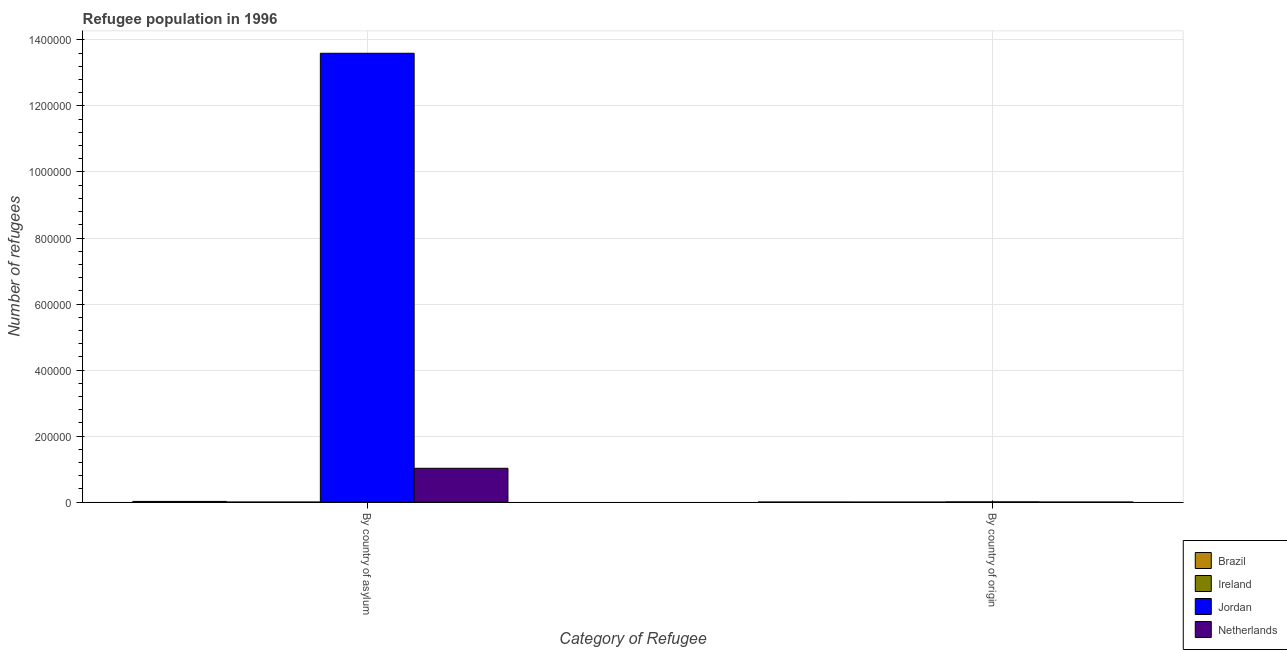Are the number of bars per tick equal to the number of legend labels?
Your response must be concise. Yes. Are the number of bars on each tick of the X-axis equal?
Keep it short and to the point. Yes. What is the label of the 1st group of bars from the left?
Make the answer very short. By country of asylum. What is the number of refugees by country of asylum in Ireland?
Keep it short and to the point. 69. Across all countries, what is the maximum number of refugees by country of origin?
Offer a very short reply. 708. Across all countries, what is the minimum number of refugees by country of asylum?
Give a very brief answer. 69. In which country was the number of refugees by country of origin maximum?
Your response must be concise. Jordan. In which country was the number of refugees by country of origin minimum?
Offer a terse response. Ireland. What is the total number of refugees by country of asylum in the graph?
Ensure brevity in your answer.  1.46e+06. What is the difference between the number of refugees by country of asylum in Netherlands and that in Jordan?
Offer a very short reply. -1.26e+06. What is the difference between the number of refugees by country of origin in Netherlands and the number of refugees by country of asylum in Ireland?
Give a very brief answer. 27. What is the average number of refugees by country of asylum per country?
Keep it short and to the point. 3.66e+05. What is the difference between the number of refugees by country of origin and number of refugees by country of asylum in Brazil?
Offer a terse response. -2127. What is the ratio of the number of refugees by country of origin in Brazil to that in Netherlands?
Provide a short and direct response. 0.89. Is the number of refugees by country of asylum in Jordan less than that in Ireland?
Offer a terse response. No. What does the 4th bar from the right in By country of asylum represents?
Your answer should be very brief. Brazil. What is the difference between two consecutive major ticks on the Y-axis?
Offer a terse response. 2.00e+05. Are the values on the major ticks of Y-axis written in scientific E-notation?
Provide a succinct answer. No. Does the graph contain any zero values?
Offer a terse response. No. How are the legend labels stacked?
Give a very brief answer. Vertical. What is the title of the graph?
Make the answer very short. Refugee population in 1996. What is the label or title of the X-axis?
Offer a terse response. Category of Refugee. What is the label or title of the Y-axis?
Provide a succinct answer. Number of refugees. What is the Number of refugees in Brazil in By country of asylum?
Offer a very short reply. 2212. What is the Number of refugees of Jordan in By country of asylum?
Keep it short and to the point. 1.36e+06. What is the Number of refugees in Netherlands in By country of asylum?
Provide a succinct answer. 1.03e+05. What is the Number of refugees in Ireland in By country of origin?
Your answer should be very brief. 2. What is the Number of refugees in Jordan in By country of origin?
Your response must be concise. 708. What is the Number of refugees of Netherlands in By country of origin?
Your answer should be very brief. 96. Across all Category of Refugee, what is the maximum Number of refugees of Brazil?
Ensure brevity in your answer.  2212. Across all Category of Refugee, what is the maximum Number of refugees in Jordan?
Offer a terse response. 1.36e+06. Across all Category of Refugee, what is the maximum Number of refugees of Netherlands?
Offer a very short reply. 1.03e+05. Across all Category of Refugee, what is the minimum Number of refugees in Ireland?
Ensure brevity in your answer.  2. Across all Category of Refugee, what is the minimum Number of refugees in Jordan?
Keep it short and to the point. 708. Across all Category of Refugee, what is the minimum Number of refugees in Netherlands?
Provide a succinct answer. 96. What is the total Number of refugees in Brazil in the graph?
Give a very brief answer. 2297. What is the total Number of refugees in Ireland in the graph?
Provide a short and direct response. 71. What is the total Number of refugees of Jordan in the graph?
Make the answer very short. 1.36e+06. What is the total Number of refugees in Netherlands in the graph?
Offer a very short reply. 1.03e+05. What is the difference between the Number of refugees of Brazil in By country of asylum and that in By country of origin?
Your answer should be very brief. 2127. What is the difference between the Number of refugees in Jordan in By country of asylum and that in By country of origin?
Your answer should be compact. 1.36e+06. What is the difference between the Number of refugees in Netherlands in By country of asylum and that in By country of origin?
Ensure brevity in your answer.  1.02e+05. What is the difference between the Number of refugees of Brazil in By country of asylum and the Number of refugees of Ireland in By country of origin?
Keep it short and to the point. 2210. What is the difference between the Number of refugees in Brazil in By country of asylum and the Number of refugees in Jordan in By country of origin?
Ensure brevity in your answer.  1504. What is the difference between the Number of refugees of Brazil in By country of asylum and the Number of refugees of Netherlands in By country of origin?
Give a very brief answer. 2116. What is the difference between the Number of refugees in Ireland in By country of asylum and the Number of refugees in Jordan in By country of origin?
Give a very brief answer. -639. What is the difference between the Number of refugees of Ireland in By country of asylum and the Number of refugees of Netherlands in By country of origin?
Offer a very short reply. -27. What is the difference between the Number of refugees of Jordan in By country of asylum and the Number of refugees of Netherlands in By country of origin?
Provide a succinct answer. 1.36e+06. What is the average Number of refugees of Brazil per Category of Refugee?
Offer a terse response. 1148.5. What is the average Number of refugees of Ireland per Category of Refugee?
Offer a very short reply. 35.5. What is the average Number of refugees in Jordan per Category of Refugee?
Provide a succinct answer. 6.80e+05. What is the average Number of refugees in Netherlands per Category of Refugee?
Make the answer very short. 5.13e+04. What is the difference between the Number of refugees of Brazil and Number of refugees of Ireland in By country of asylum?
Ensure brevity in your answer.  2143. What is the difference between the Number of refugees in Brazil and Number of refugees in Jordan in By country of asylum?
Offer a very short reply. -1.36e+06. What is the difference between the Number of refugees in Brazil and Number of refugees in Netherlands in By country of asylum?
Your answer should be very brief. -1.00e+05. What is the difference between the Number of refugees of Ireland and Number of refugees of Jordan in By country of asylum?
Offer a very short reply. -1.36e+06. What is the difference between the Number of refugees of Ireland and Number of refugees of Netherlands in By country of asylum?
Provide a short and direct response. -1.03e+05. What is the difference between the Number of refugees in Jordan and Number of refugees in Netherlands in By country of asylum?
Your response must be concise. 1.26e+06. What is the difference between the Number of refugees in Brazil and Number of refugees in Ireland in By country of origin?
Provide a succinct answer. 83. What is the difference between the Number of refugees of Brazil and Number of refugees of Jordan in By country of origin?
Offer a very short reply. -623. What is the difference between the Number of refugees in Ireland and Number of refugees in Jordan in By country of origin?
Your answer should be very brief. -706. What is the difference between the Number of refugees of Ireland and Number of refugees of Netherlands in By country of origin?
Your response must be concise. -94. What is the difference between the Number of refugees of Jordan and Number of refugees of Netherlands in By country of origin?
Keep it short and to the point. 612. What is the ratio of the Number of refugees of Brazil in By country of asylum to that in By country of origin?
Provide a short and direct response. 26.02. What is the ratio of the Number of refugees in Ireland in By country of asylum to that in By country of origin?
Keep it short and to the point. 34.5. What is the ratio of the Number of refugees in Jordan in By country of asylum to that in By country of origin?
Ensure brevity in your answer.  1920.31. What is the ratio of the Number of refugees in Netherlands in By country of asylum to that in By country of origin?
Your response must be concise. 1068.62. What is the difference between the highest and the second highest Number of refugees of Brazil?
Offer a very short reply. 2127. What is the difference between the highest and the second highest Number of refugees of Jordan?
Ensure brevity in your answer.  1.36e+06. What is the difference between the highest and the second highest Number of refugees in Netherlands?
Ensure brevity in your answer.  1.02e+05. What is the difference between the highest and the lowest Number of refugees of Brazil?
Provide a succinct answer. 2127. What is the difference between the highest and the lowest Number of refugees in Ireland?
Offer a very short reply. 67. What is the difference between the highest and the lowest Number of refugees in Jordan?
Ensure brevity in your answer.  1.36e+06. What is the difference between the highest and the lowest Number of refugees of Netherlands?
Give a very brief answer. 1.02e+05. 